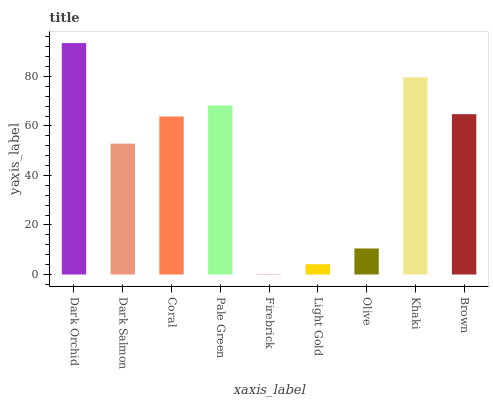Is Firebrick the minimum?
Answer yes or no. Yes. Is Dark Orchid the maximum?
Answer yes or no. Yes. Is Dark Salmon the minimum?
Answer yes or no. No. Is Dark Salmon the maximum?
Answer yes or no. No. Is Dark Orchid greater than Dark Salmon?
Answer yes or no. Yes. Is Dark Salmon less than Dark Orchid?
Answer yes or no. Yes. Is Dark Salmon greater than Dark Orchid?
Answer yes or no. No. Is Dark Orchid less than Dark Salmon?
Answer yes or no. No. Is Coral the high median?
Answer yes or no. Yes. Is Coral the low median?
Answer yes or no. Yes. Is Firebrick the high median?
Answer yes or no. No. Is Pale Green the low median?
Answer yes or no. No. 